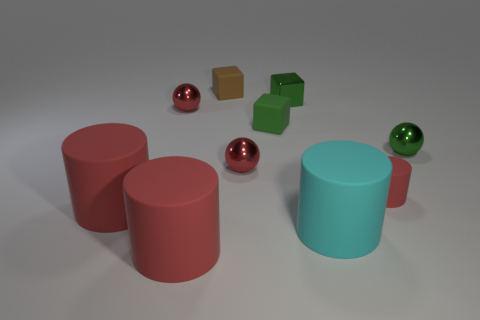How many tiny things are red balls or brown rubber objects?
Ensure brevity in your answer.  3. The tiny matte object that is left of the green metal block and in front of the metallic block is what color?
Provide a succinct answer. Green. Are the big cyan cylinder and the small green sphere made of the same material?
Offer a terse response. No. The green rubber object has what shape?
Ensure brevity in your answer.  Cube. There is a big cylinder that is right of the tiny red metal ball in front of the small green shiny ball; how many objects are on the right side of it?
Your answer should be very brief. 2. There is another rubber thing that is the same shape as the tiny brown thing; what color is it?
Provide a short and direct response. Green. What shape is the red shiny thing to the right of the brown cube on the left side of the red rubber object on the right side of the tiny brown matte cube?
Offer a terse response. Sphere. How big is the red cylinder that is behind the big cyan cylinder and on the left side of the tiny red cylinder?
Your response must be concise. Large. Are there fewer big rubber cylinders than large gray shiny blocks?
Keep it short and to the point. No. There is a green shiny thing that is to the left of the cyan thing; what size is it?
Your answer should be compact. Small. 